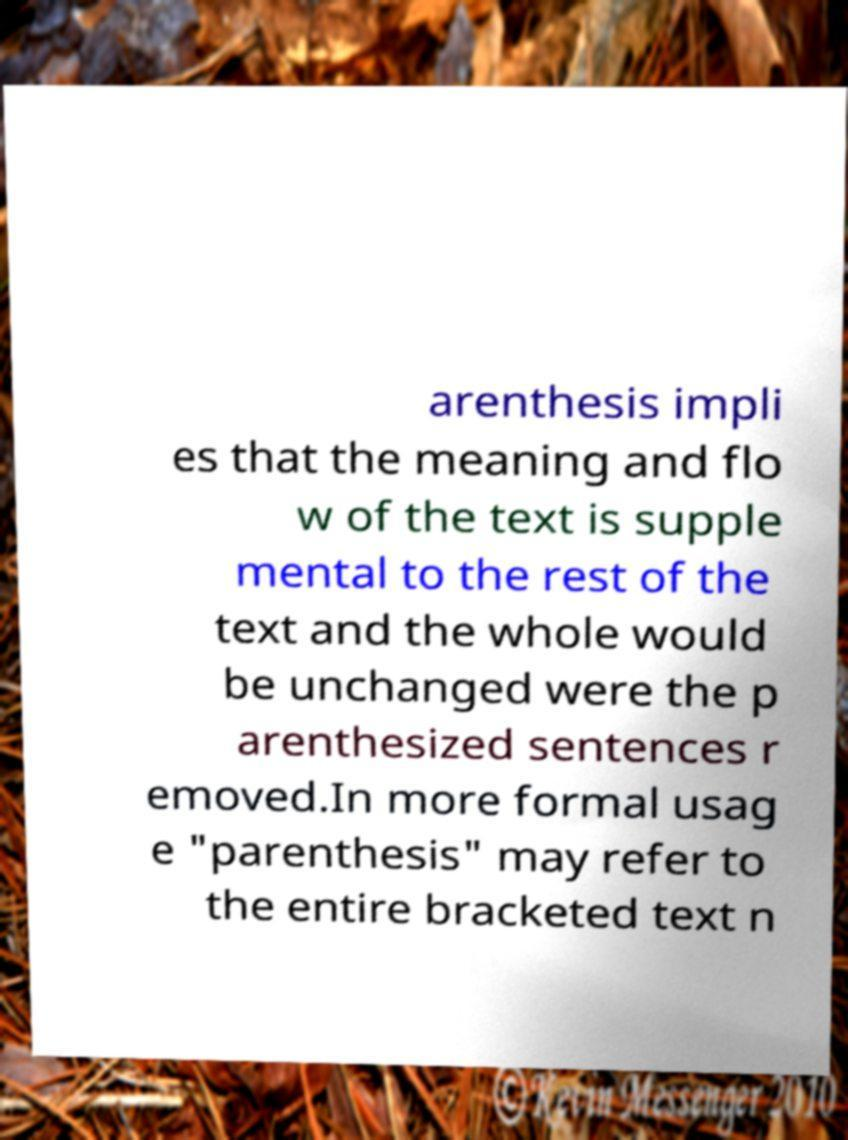I need the written content from this picture converted into text. Can you do that? arenthesis impli es that the meaning and flo w of the text is supple mental to the rest of the text and the whole would be unchanged were the p arenthesized sentences r emoved.In more formal usag e "parenthesis" may refer to the entire bracketed text n 